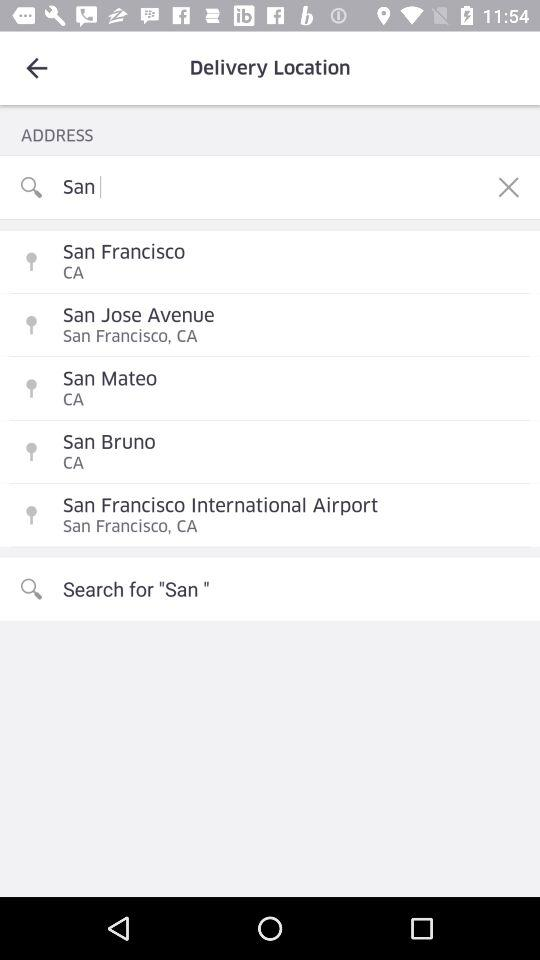Which text is input in the address field? The input text is San. 